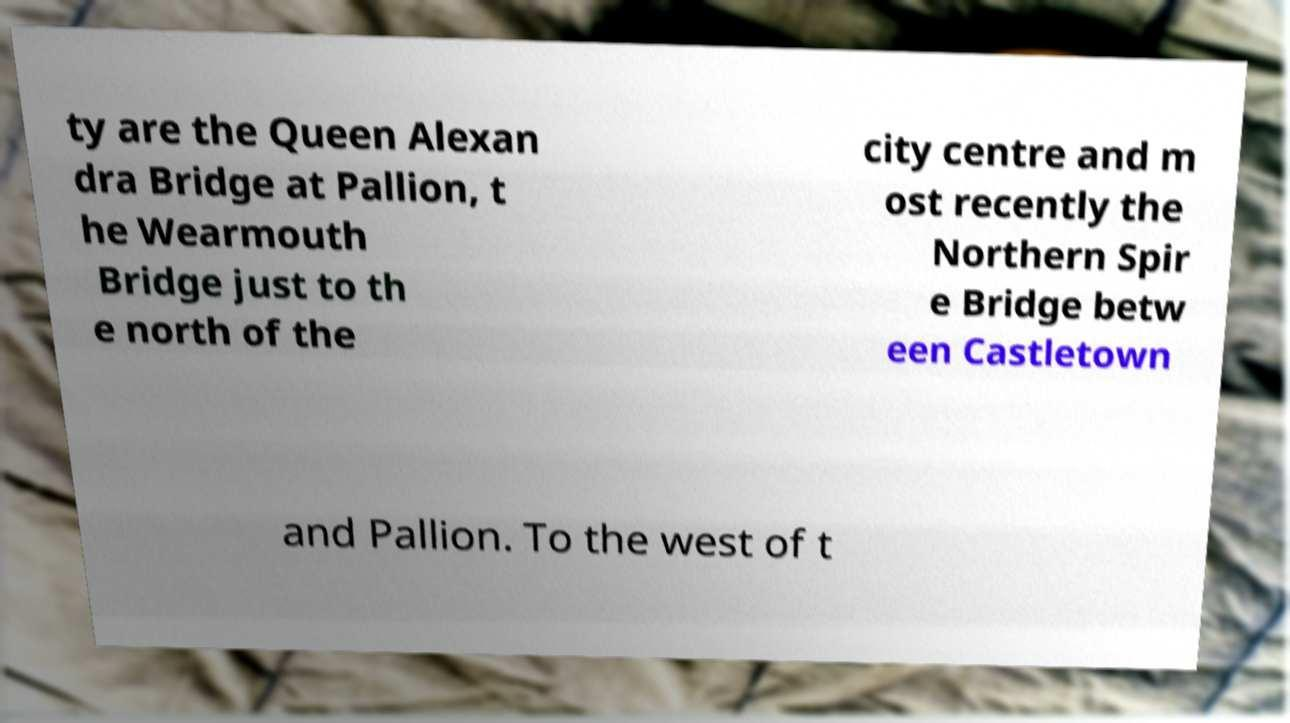There's text embedded in this image that I need extracted. Can you transcribe it verbatim? ty are the Queen Alexan dra Bridge at Pallion, t he Wearmouth Bridge just to th e north of the city centre and m ost recently the Northern Spir e Bridge betw een Castletown and Pallion. To the west of t 